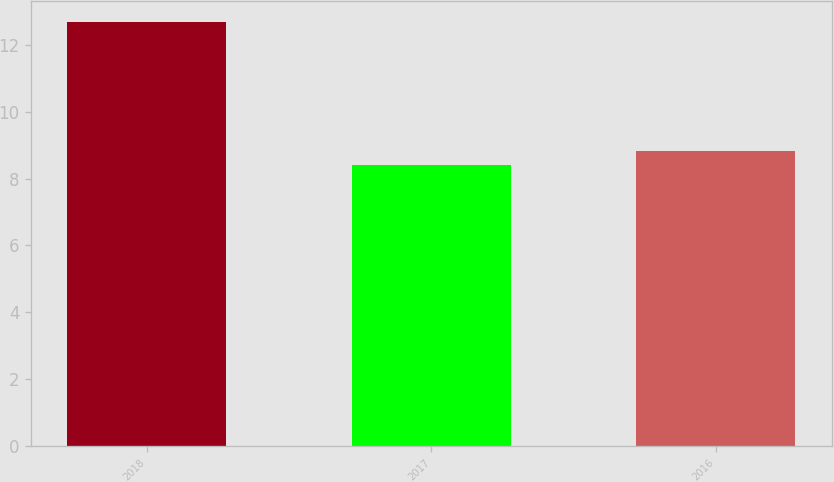<chart> <loc_0><loc_0><loc_500><loc_500><bar_chart><fcel>2018<fcel>2017<fcel>2016<nl><fcel>12.7<fcel>8.4<fcel>8.83<nl></chart> 